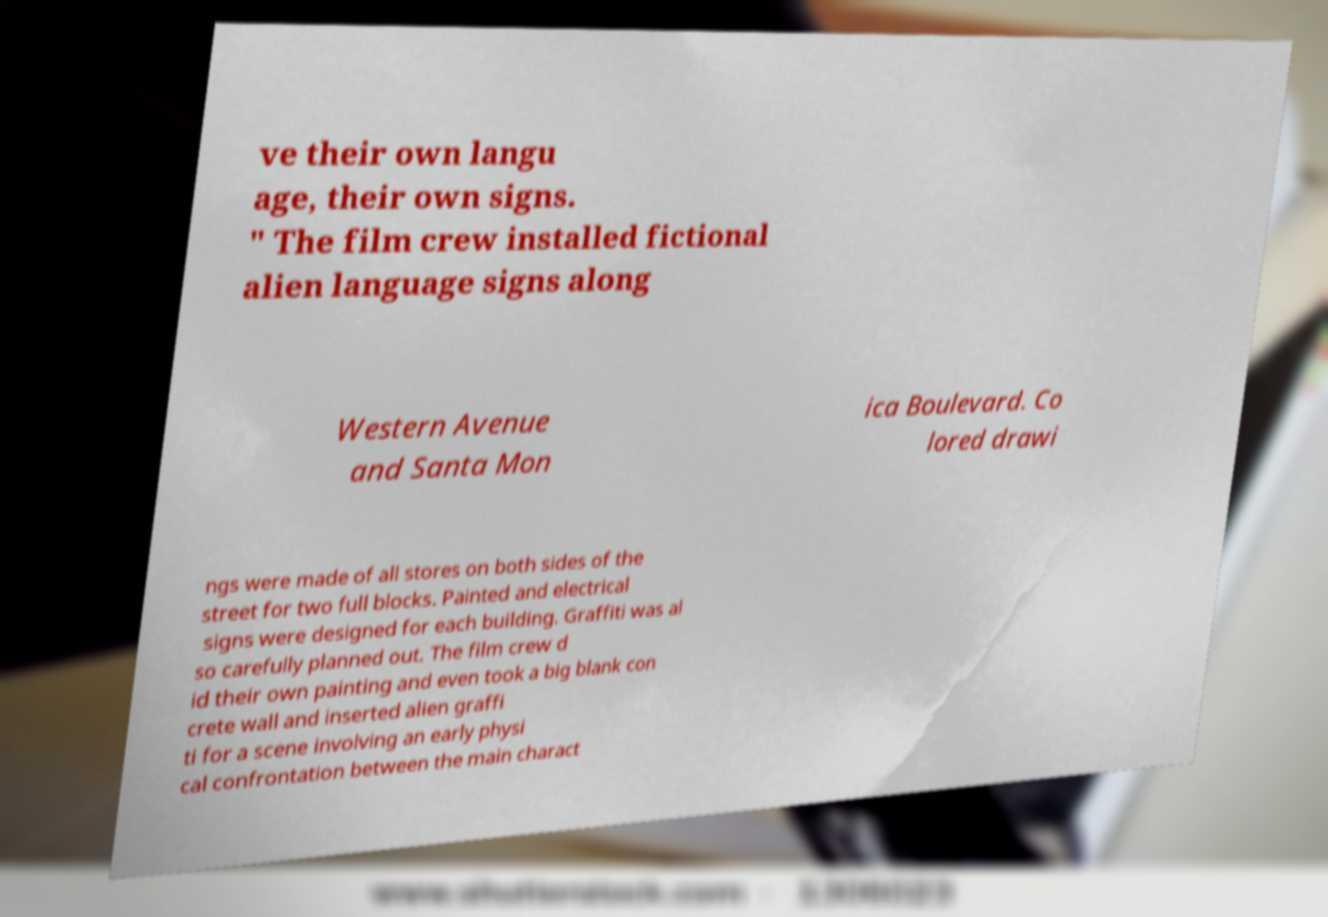Can you read and provide the text displayed in the image?This photo seems to have some interesting text. Can you extract and type it out for me? ve their own langu age, their own signs. " The film crew installed fictional alien language signs along Western Avenue and Santa Mon ica Boulevard. Co lored drawi ngs were made of all stores on both sides of the street for two full blocks. Painted and electrical signs were designed for each building. Graffiti was al so carefully planned out. The film crew d id their own painting and even took a big blank con crete wall and inserted alien graffi ti for a scene involving an early physi cal confrontation between the main charact 